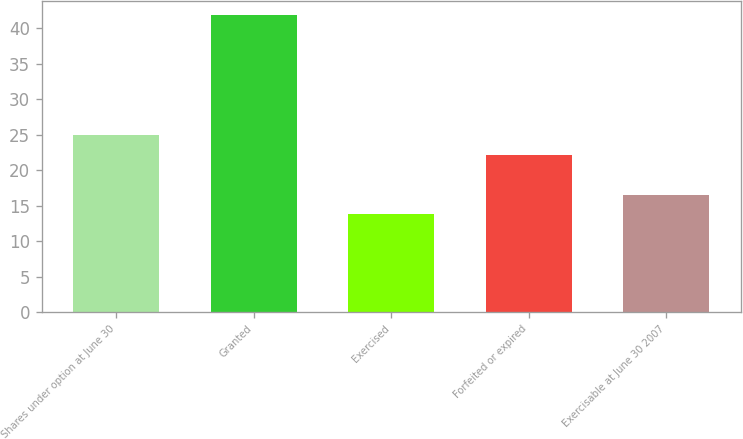Convert chart. <chart><loc_0><loc_0><loc_500><loc_500><bar_chart><fcel>Shares under option at June 30<fcel>Granted<fcel>Exercised<fcel>Forfeited or expired<fcel>Exercisable at June 30 2007<nl><fcel>24.95<fcel>41.79<fcel>13.75<fcel>22.15<fcel>16.55<nl></chart> 